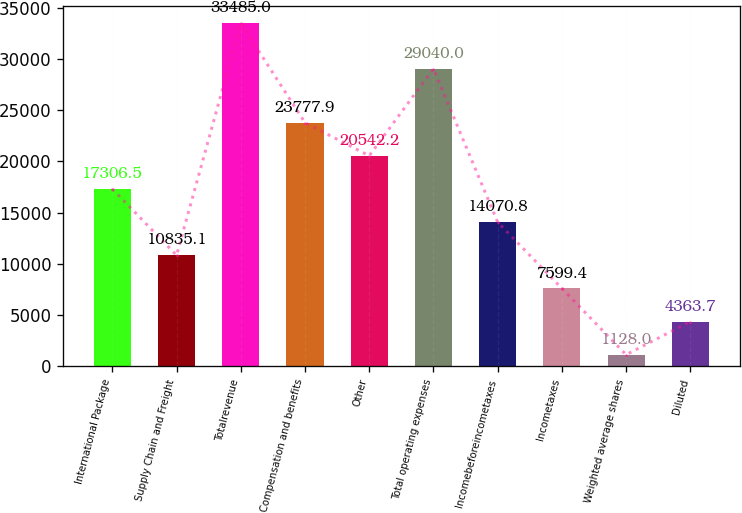Convert chart to OTSL. <chart><loc_0><loc_0><loc_500><loc_500><bar_chart><fcel>International Package<fcel>Supply Chain and Freight<fcel>Totalrevenue<fcel>Compensation and benefits<fcel>Other<fcel>Total operating expenses<fcel>Incomebeforeincometaxes<fcel>Incometaxes<fcel>Weighted average shares<fcel>Diluted<nl><fcel>17306.5<fcel>10835.1<fcel>33485<fcel>23777.9<fcel>20542.2<fcel>29040<fcel>14070.8<fcel>7599.4<fcel>1128<fcel>4363.7<nl></chart> 